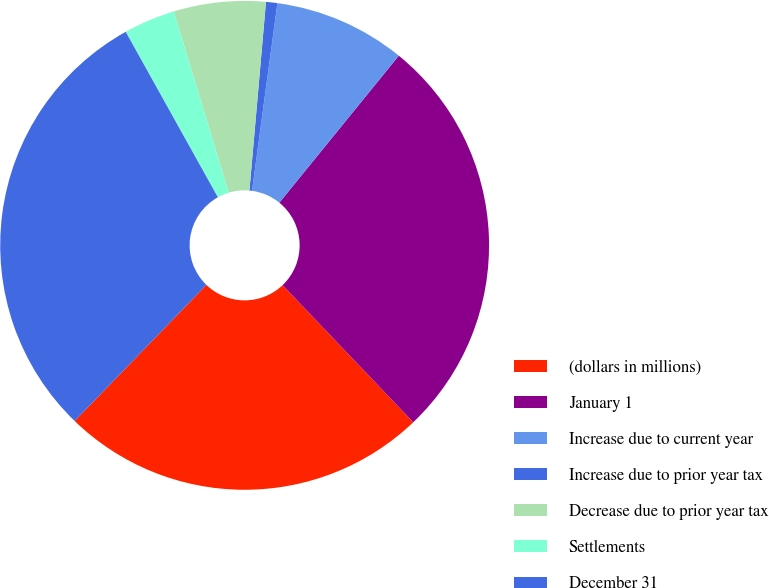<chart> <loc_0><loc_0><loc_500><loc_500><pie_chart><fcel>(dollars in millions)<fcel>January 1<fcel>Increase due to current year<fcel>Increase due to prior year tax<fcel>Decrease due to prior year tax<fcel>Settlements<fcel>December 31<nl><fcel>24.36%<fcel>27.02%<fcel>8.72%<fcel>0.75%<fcel>6.07%<fcel>3.41%<fcel>29.67%<nl></chart> 